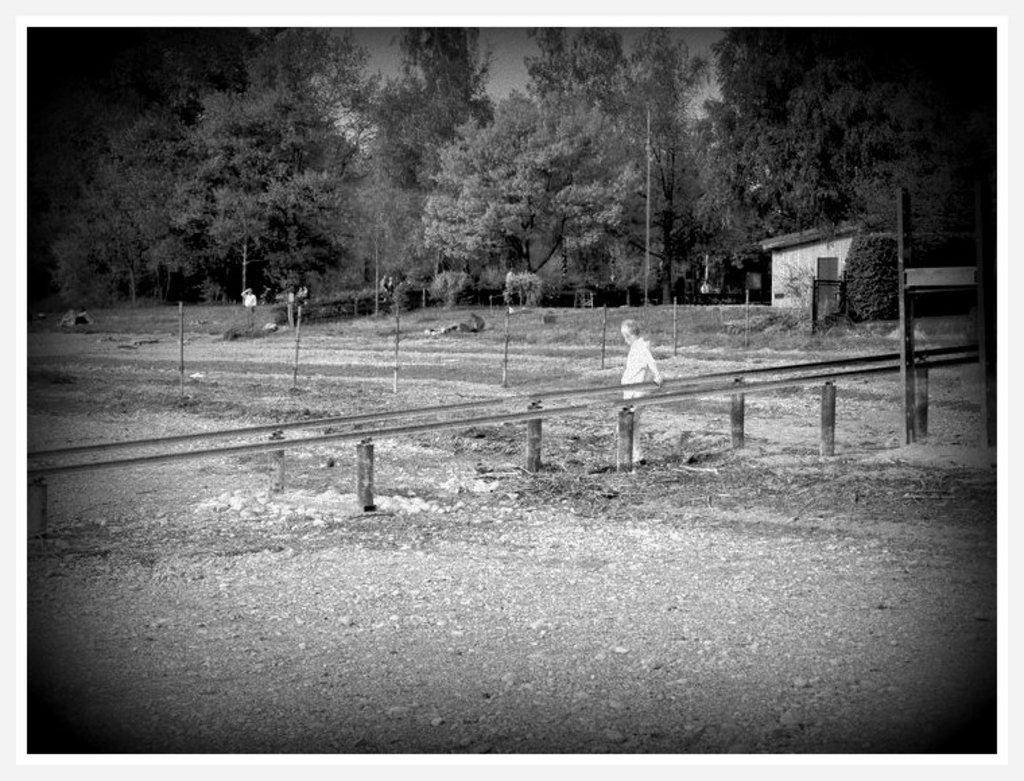Please provide a concise description of this image. In this image there is a person standing, beside the person there is a wooden fence and barbed wire fence. In the background of the image there are trees, lamp posts, bushes and a wooden house. 